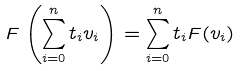<formula> <loc_0><loc_0><loc_500><loc_500>F \left ( \sum _ { i = 0 } ^ { n } t _ { i } v _ { i } \right ) = \sum _ { i = 0 } ^ { n } t _ { i } F ( v _ { i } )</formula> 